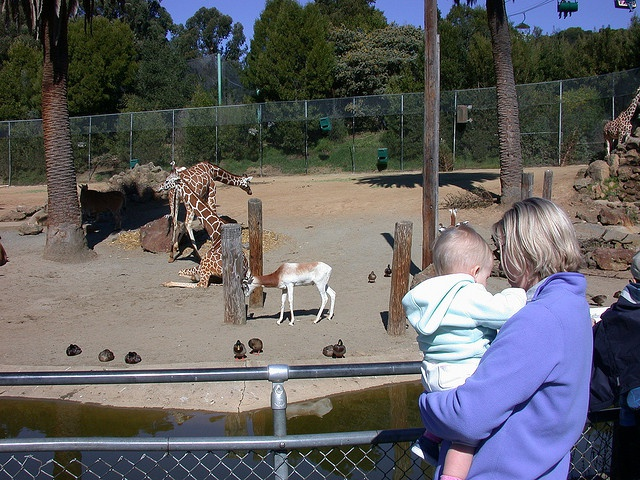Describe the objects in this image and their specific colors. I can see people in black, violet, gray, and darkgray tones, people in black, white, pink, darkgray, and gray tones, people in black, navy, darkblue, and gray tones, giraffe in black, maroon, lightgray, gray, and darkgray tones, and giraffe in black, gray, darkgray, and maroon tones in this image. 